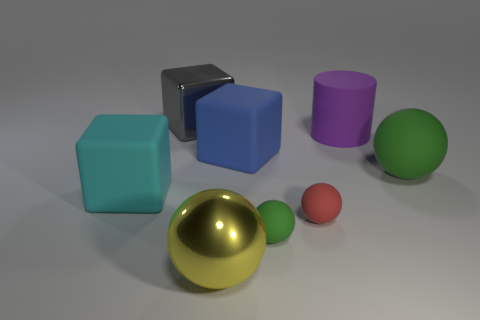Subtract all purple cylinders. How many green spheres are left? 2 Subtract all tiny red spheres. How many spheres are left? 3 Add 2 tiny red metal cubes. How many objects exist? 10 Subtract 1 blocks. How many blocks are left? 2 Subtract all red spheres. How many spheres are left? 3 Subtract all cylinders. How many objects are left? 7 Subtract all blue balls. Subtract all red cubes. How many balls are left? 4 Add 3 big shiny things. How many big shiny things exist? 5 Subtract 0 cyan cylinders. How many objects are left? 8 Subtract all large red rubber cylinders. Subtract all big blue things. How many objects are left? 7 